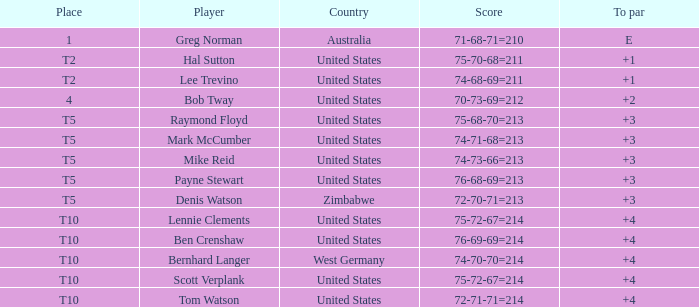Who is the player with a +3 to par and a 74-71-68=213 score? Mark McCumber. 